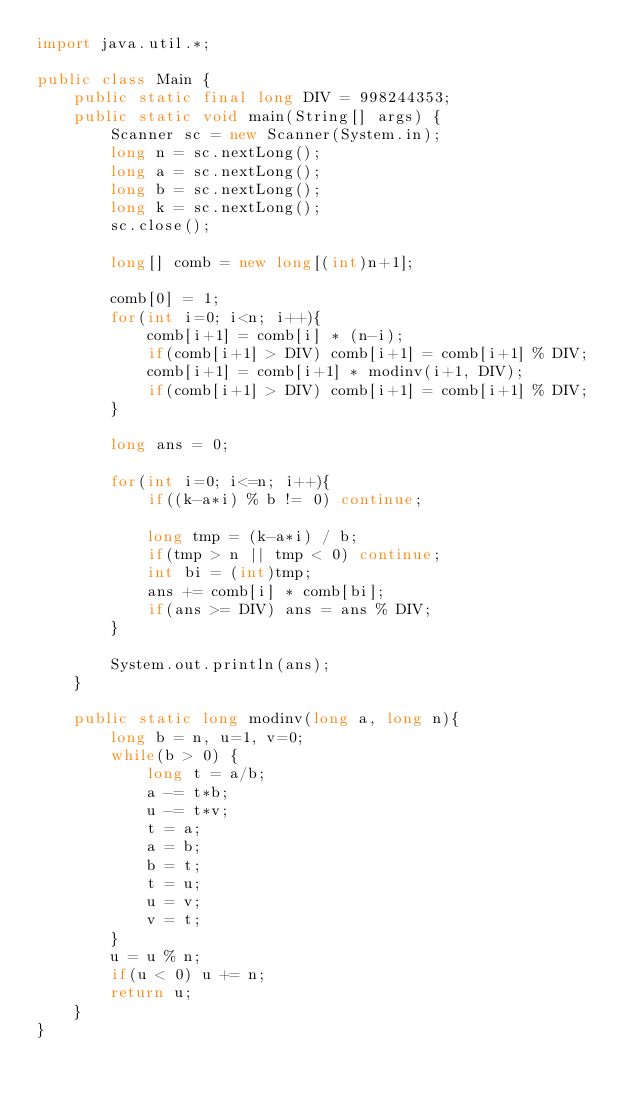Convert code to text. <code><loc_0><loc_0><loc_500><loc_500><_Java_>import java.util.*;

public class Main {
    public static final long DIV = 998244353;
    public static void main(String[] args) {
        Scanner sc = new Scanner(System.in);
        long n = sc.nextLong();
        long a = sc.nextLong();
        long b = sc.nextLong();
        long k = sc.nextLong();
        sc.close();

        long[] comb = new long[(int)n+1];

        comb[0] = 1;
        for(int i=0; i<n; i++){
            comb[i+1] = comb[i] * (n-i);
            if(comb[i+1] > DIV) comb[i+1] = comb[i+1] % DIV;
            comb[i+1] = comb[i+1] * modinv(i+1, DIV);
            if(comb[i+1] > DIV) comb[i+1] = comb[i+1] % DIV;
        }

        long ans = 0;

        for(int i=0; i<=n; i++){
            if((k-a*i) % b != 0) continue;

            long tmp = (k-a*i) / b;
            if(tmp > n || tmp < 0) continue;
            int bi = (int)tmp;
            ans += comb[i] * comb[bi];
            if(ans >= DIV) ans = ans % DIV;
        }

        System.out.println(ans);
    }

    public static long modinv(long a, long n){
        long b = n, u=1, v=0;
        while(b > 0) {
            long t = a/b;
            a -= t*b;
            u -= t*v;
            t = a;
            a = b;
            b = t;
            t = u;
            u = v;
            v = t;
        }
        u = u % n;
        if(u < 0) u += n;
        return u;
    }
}</code> 